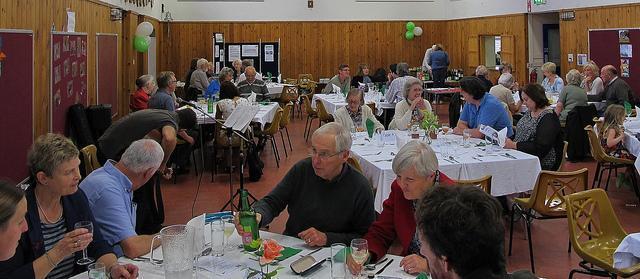How many balloons are shown?
Give a very brief answer. 6. How many chairs are there?
Give a very brief answer. 2. How many dining tables are in the photo?
Give a very brief answer. 2. How many people are in the photo?
Give a very brief answer. 7. 